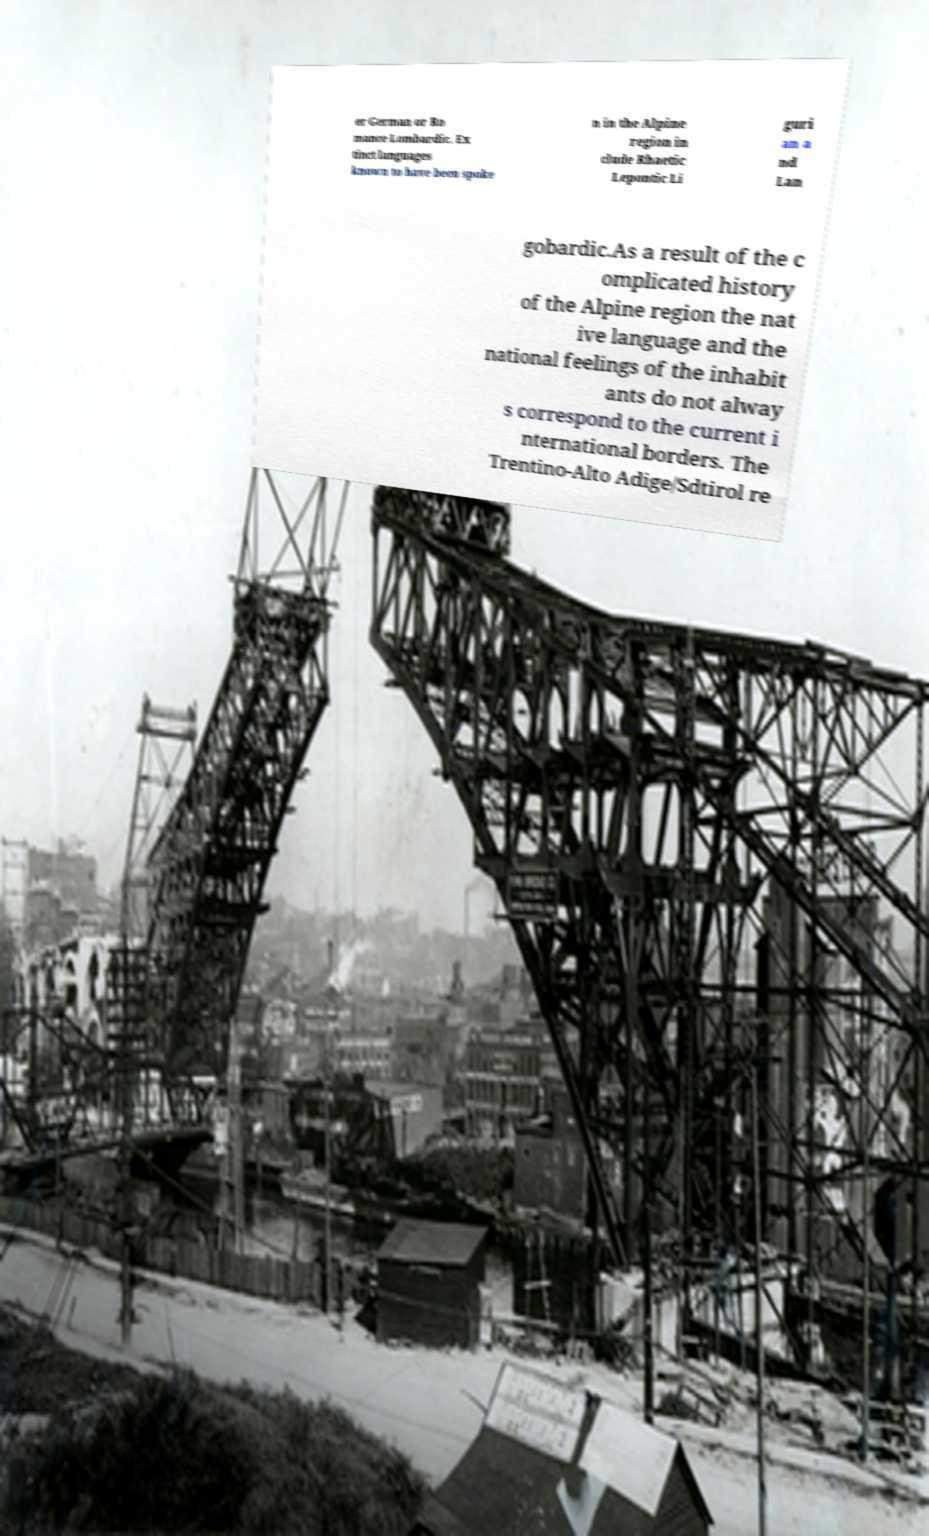For documentation purposes, I need the text within this image transcribed. Could you provide that? er German or Ro mance Lombardic. Ex tinct languages known to have been spoke n in the Alpine region in clude Rhaetic Lepontic Li guri an a nd Lan gobardic.As a result of the c omplicated history of the Alpine region the nat ive language and the national feelings of the inhabit ants do not alway s correspond to the current i nternational borders. The Trentino-Alto Adige/Sdtirol re 